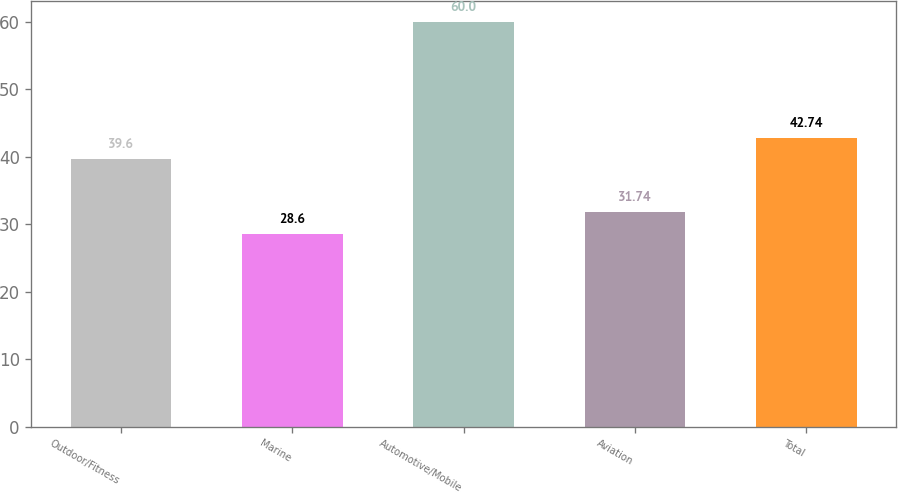<chart> <loc_0><loc_0><loc_500><loc_500><bar_chart><fcel>Outdoor/Fitness<fcel>Marine<fcel>Automotive/Mobile<fcel>Aviation<fcel>Total<nl><fcel>39.6<fcel>28.6<fcel>60<fcel>31.74<fcel>42.74<nl></chart> 